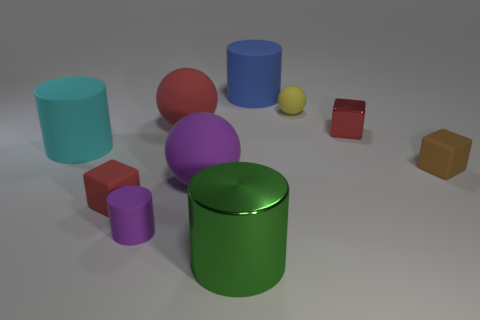Subtract all brown cylinders. Subtract all brown spheres. How many cylinders are left? 4 Subtract all tiny things. Subtract all matte cylinders. How many objects are left? 2 Add 8 large green metallic things. How many large green metallic things are left? 9 Add 5 tiny red rubber cubes. How many tiny red rubber cubes exist? 6 Subtract 1 red cubes. How many objects are left? 9 Subtract all cylinders. How many objects are left? 6 